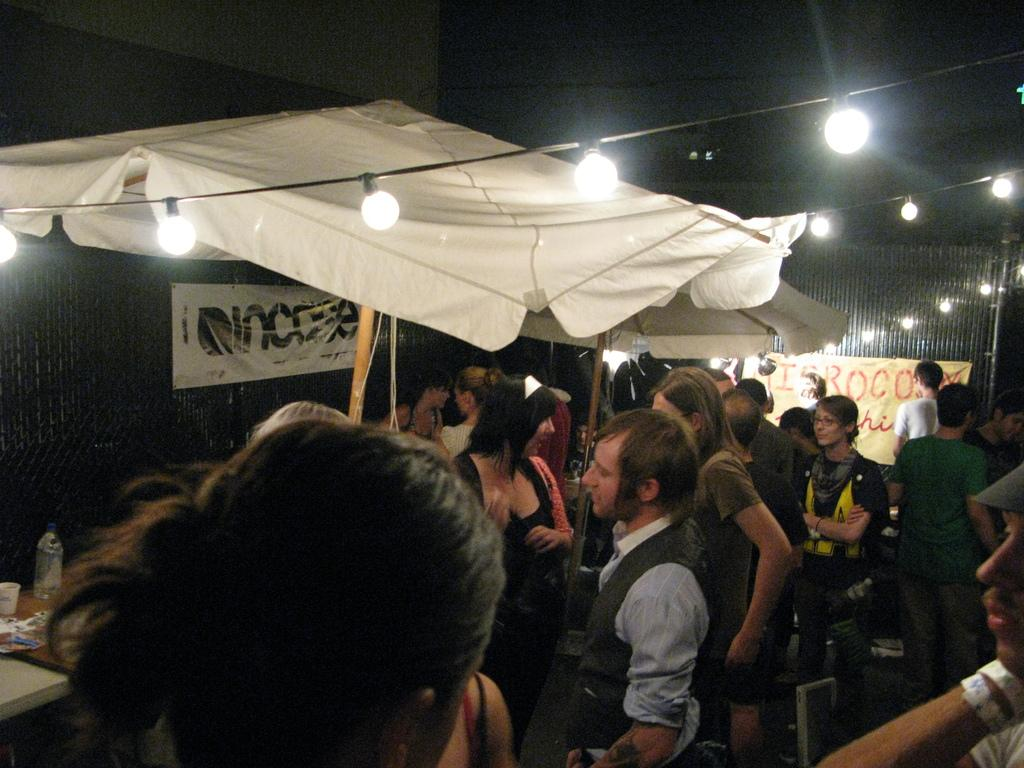How many individuals are present in the image? There are many people in the image. What can be seen at the top of the image? There are lights visible at the top of the image. What objects are present in the image that resemble sticks? There are two sticks in the image. Where is the paper with text located in the image? The paper with text is on the right side of the image. Who is the mom in the image? There is no mom present in the image. What type of parcel is being delivered by the people in the image? There is no parcel visible in the image. 